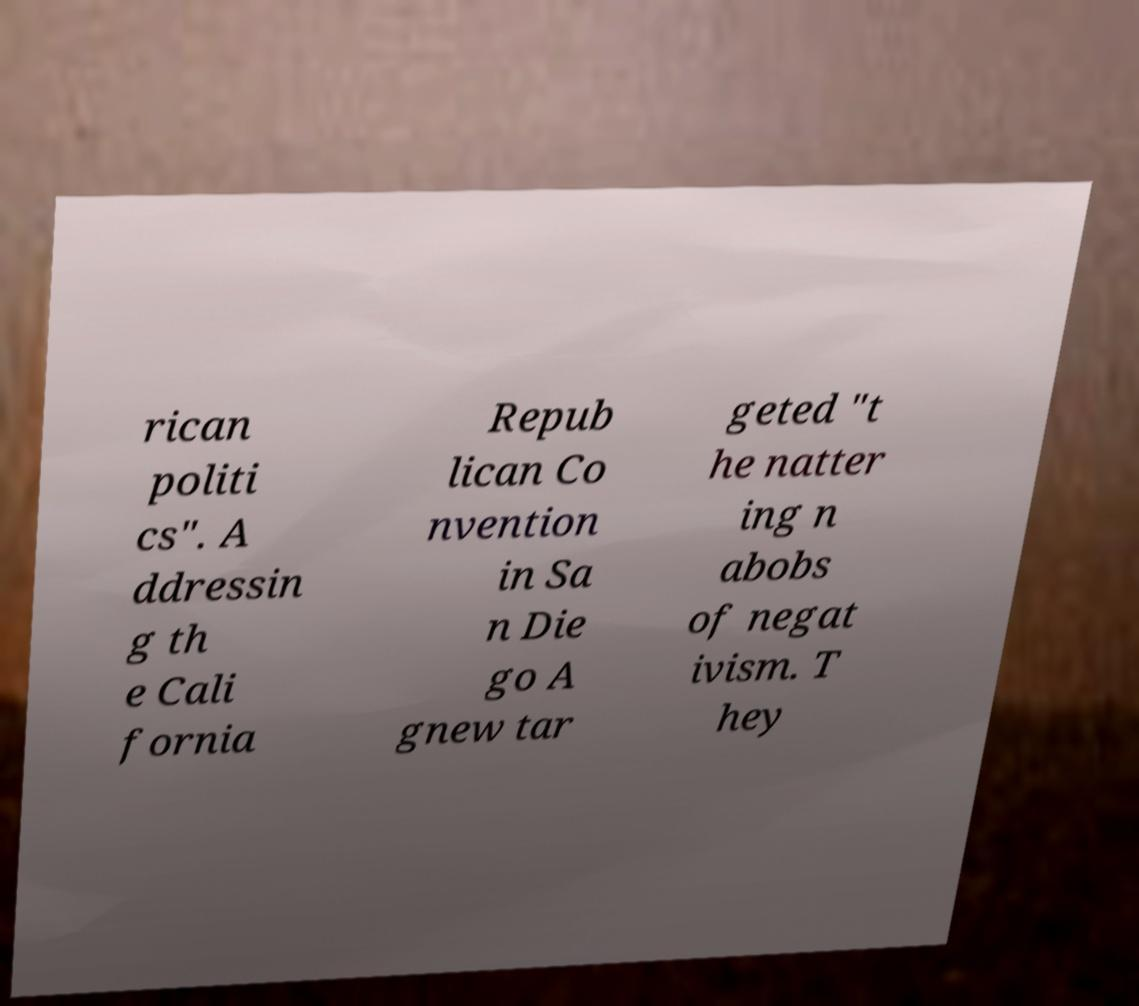What messages or text are displayed in this image? I need them in a readable, typed format. rican politi cs". A ddressin g th e Cali fornia Repub lican Co nvention in Sa n Die go A gnew tar geted "t he natter ing n abobs of negat ivism. T hey 